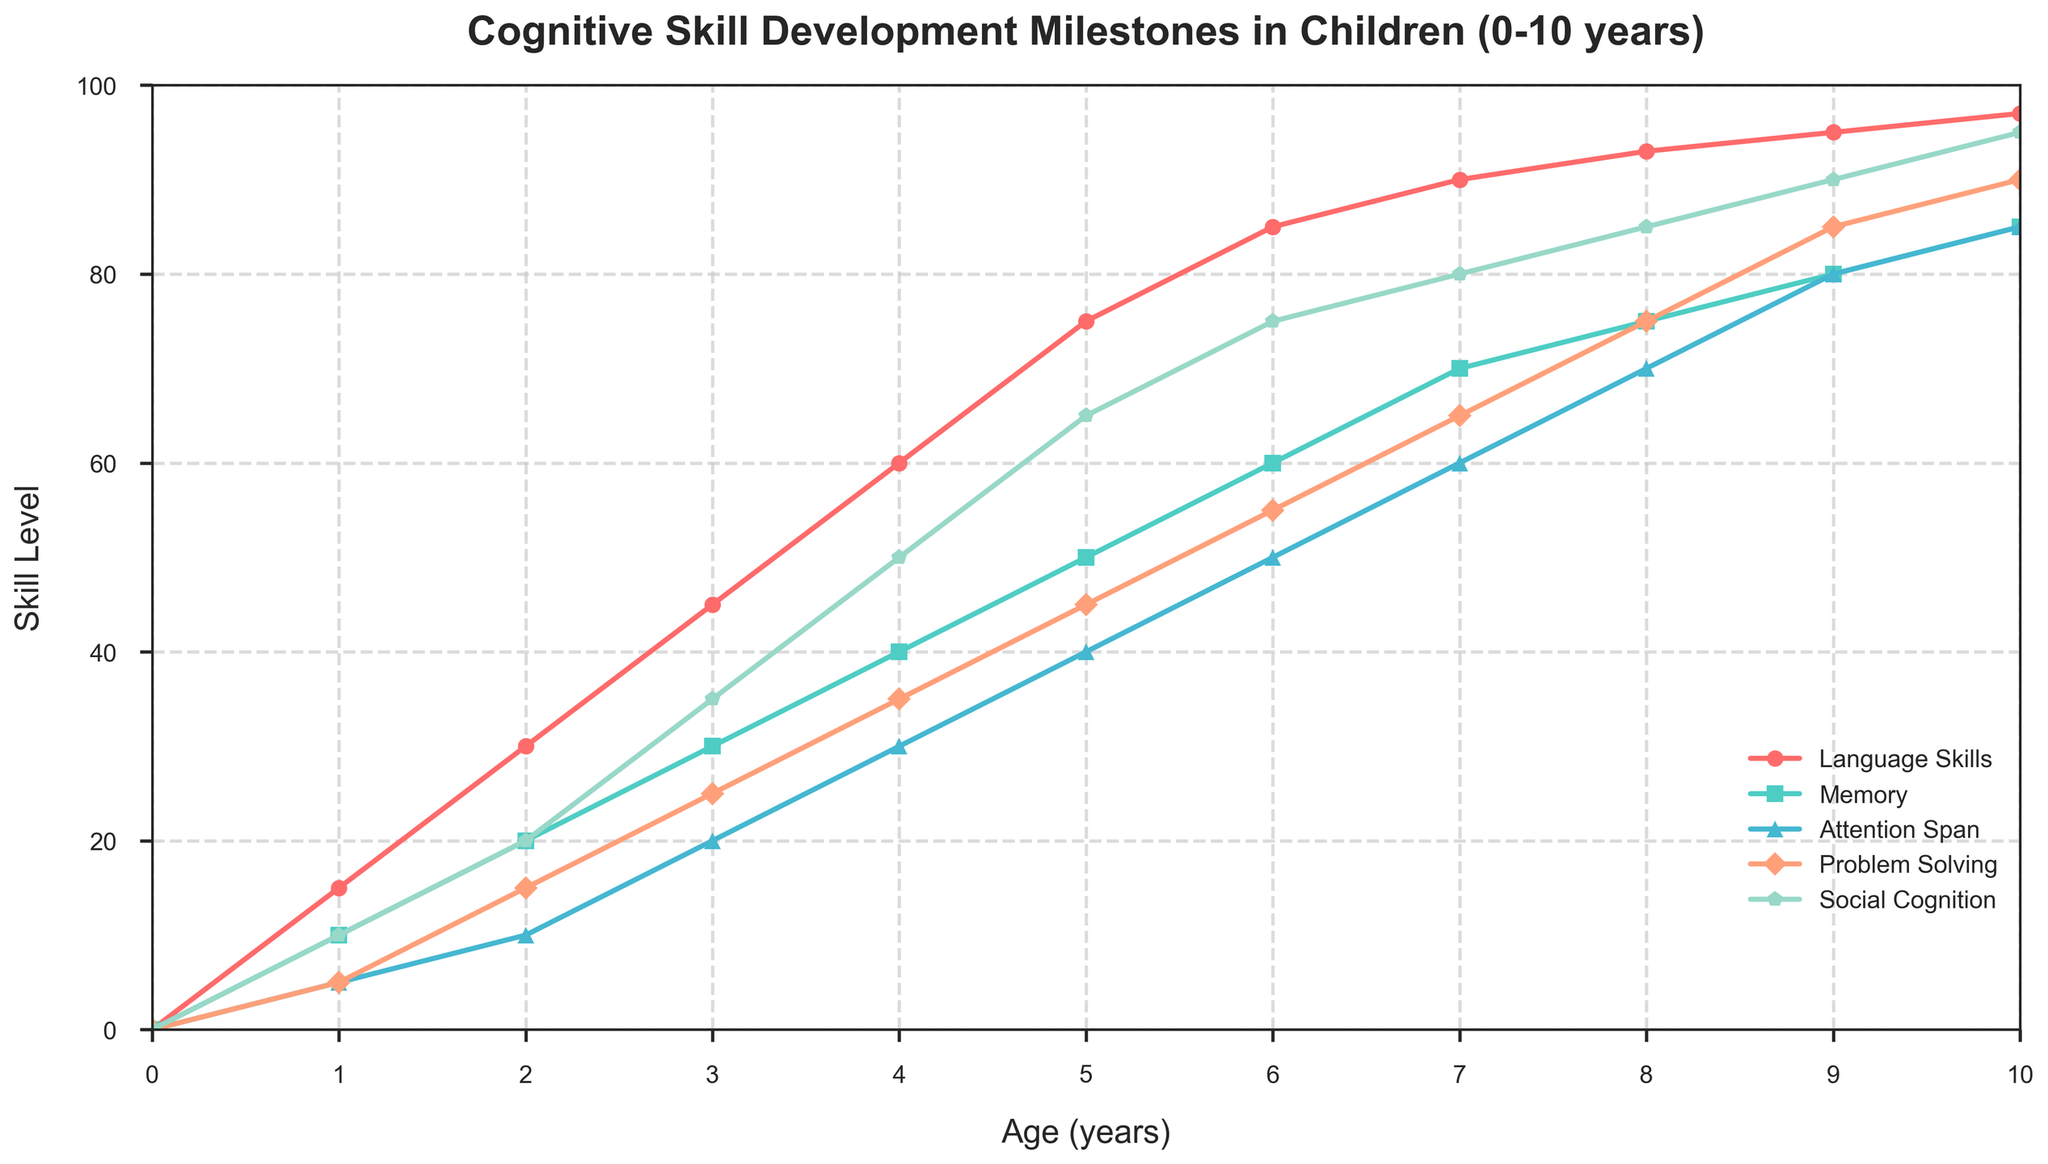What age does Problem Solving skill level first surpass 50? At the age of 6, the Problem Solving skill level reaches 55, which is the first time it surpasses 50. This can be seen by inspecting the Problem Solving line and its values at each age.
Answer: 6 years Between ages 5 and 7, which cognitive skill shows the least improvement? By comparing the differences in skill levels for each cognitive skill from age 5 to age 7, we find that Language Skills increase by 15 (from 75 to 90), Memory by 20 (from 50 to 70), Attention Span by 20 (from 40 to 60), Problem Solving by 20 (from 45 to 65), and Social Cognition by 15 (from 65 to 80). The smallest increase is in Language Skills and Social Cognition, both with an increase of 15.
Answer: Language Skills and Social Cognition Which cognitive skill reaches the highest level at age 10? The plot shows the levels of all five cognitive skills at age 10. At this age, Social Cognition reaches the highest level at 95.
Answer: Social Cognition How does the development of Memory compare to Problem Solving between ages 4 and 6? From age 4 to age 6, Memory improves from 40 to 60 (an increase of 20), while Problem Solving improves from 35 to 55 (an increase of 20). Both skills increase by the same amount during this period.
Answer: Memory and Problem Solving improve equally At what ages do all cognitive skills exceed 50? Referring to the chart, by age 6, all cognitive skills have exceeded the level of 50. Social Cognition exceeds 50 first at age 4, followed by Language Skills and Memory by age 6, Attention Span and Problem Solving reach 50 at ages 5 and 6 respectively.
Answer: 6 years What is the average skill level for Attention Span across all ages? To find the average skill level of Attention Span, sum all its values: (0 + 5 + 10 + 20 + 30 + 40 + 50 + 60 + 70 + 80 + 85) = 450. There are 11 data points, so the average is 450/11 = 40.91.
Answer: 40.91 Which cognitive skill shows the steepest growth between ages 1 and 3? The increase in skill levels between ages 1 and 3 are: Language Skills (from 15 to 45, increase of 30), Memory (from 10 to 30, increase of 20), Attention Span (from 5 to 20, increase of 15), Problem Solving (from 5 to 25, increase of 20), and Social Cognition (from 10 to 35, increase of 25). Language Skills shows the steepest growth with an increase of 30.
Answer: Language Skills How does the trend in Social Cognition compare visually to that of Memory across all ages? Visually, both Social Cognition and Memory show an upward trend from age 0 to 10. However, Social Cognition consistently rises at a slightly steeper angle and reaches higher levels, indicating faster and higher overall development compared to Memory.
Answer: Social Cognition rises faster and higher What is the overall increase in Attention Span from age 0 to age 10? From age 0 to 10, Attention Span increases from 0 to 85, resulting in an overall increase of 85. This can be seen by comparing the Attention Span levels at ages 0 and 10.
Answer: 85 Between what ages does Language Skills show the greatest increase per year? By examining the yearly changes in Language Skills, the greatest increase per year occurs between ages 1 and 4, with increases of 15, 15, and 15 per year respectively.
Answer: 1-4 years 